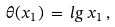<formula> <loc_0><loc_0><loc_500><loc_500>\theta ( x _ { 1 } ) \, = \, l g \, x _ { 1 } \, ,</formula> 